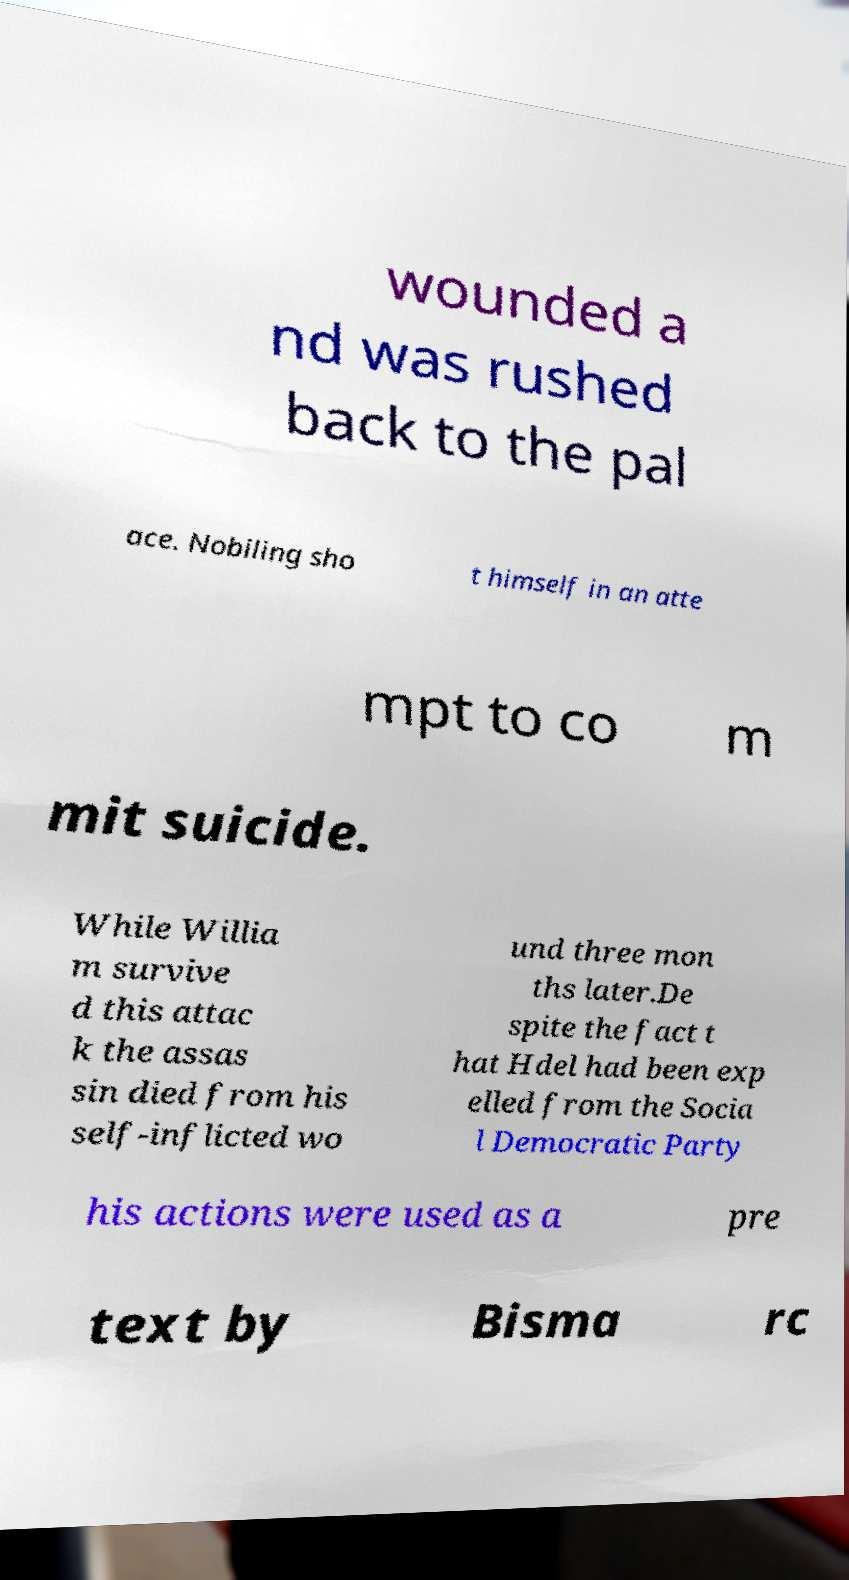I need the written content from this picture converted into text. Can you do that? wounded a nd was rushed back to the pal ace. Nobiling sho t himself in an atte mpt to co m mit suicide. While Willia m survive d this attac k the assas sin died from his self-inflicted wo und three mon ths later.De spite the fact t hat Hdel had been exp elled from the Socia l Democratic Party his actions were used as a pre text by Bisma rc 